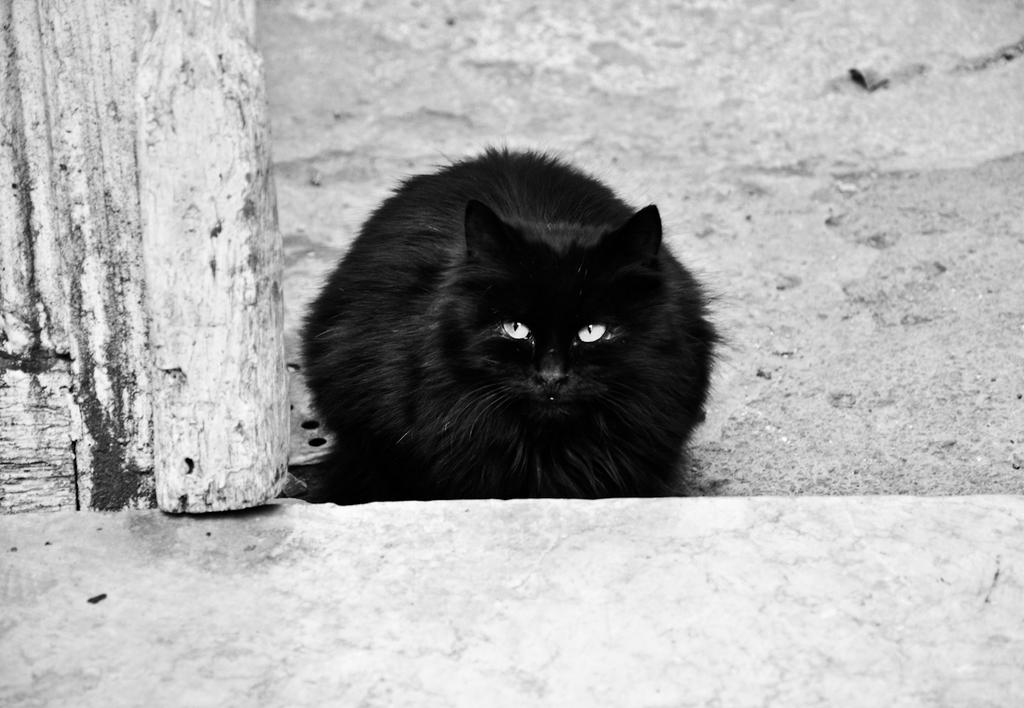What type of animal is in the image? There is a black cat in the image. Where is the cat located in the image? The cat is sitting on a wall. What is the cat's reaction to the disgusting smell in the image? There is no indication of a disgusting smell or any reaction from the cat in the image. 